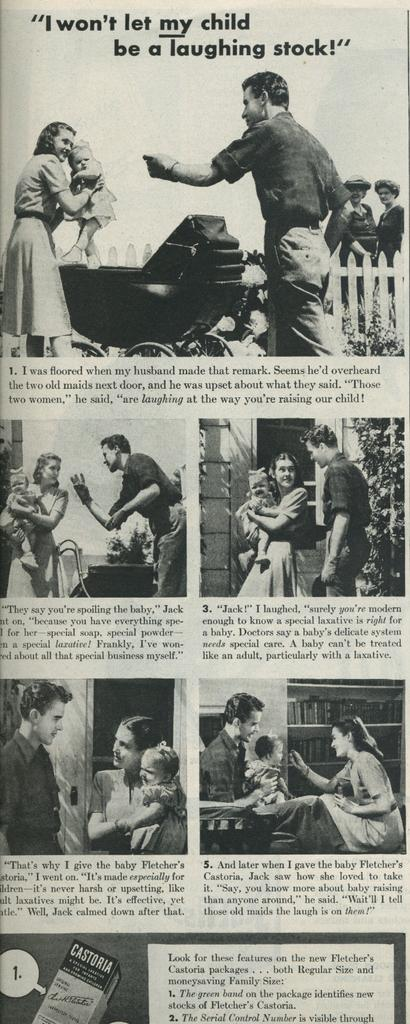What is the main object in the image? The image contains a newspaper. What can be seen in the newspaper? There are pictures of a man, a woman, and a kid in the newspaper. Is there any text in the newspaper? Yes, there is text in the newspaper. How many bikes are parked next to the newspaper in the image? There are no bikes present in the image; it only contains a newspaper with pictures and text. Can you describe the kiss between the man and woman in the image? There is no kiss depicted in the image; it only contains pictures of a man, a woman, and a kid, as well as text. 